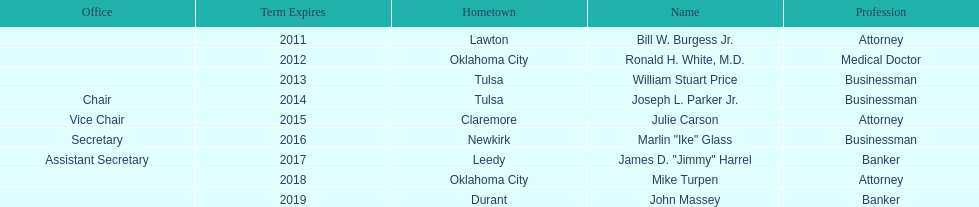How many members had businessman listed as their profession? 3. 